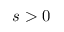Convert formula to latex. <formula><loc_0><loc_0><loc_500><loc_500>s > 0</formula> 